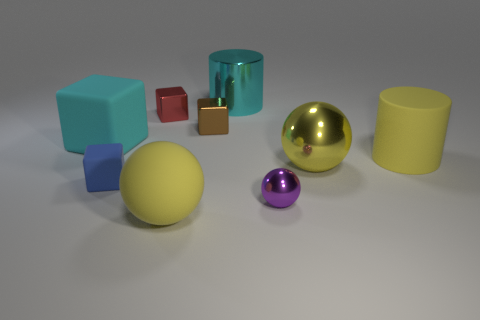Subtract all red blocks. How many yellow balls are left? 2 Subtract all large yellow rubber balls. How many balls are left? 2 Subtract 2 blocks. How many blocks are left? 2 Add 1 large yellow shiny objects. How many objects exist? 10 Subtract all cyan blocks. How many blocks are left? 3 Subtract all cylinders. How many objects are left? 7 Subtract 0 green blocks. How many objects are left? 9 Subtract all purple blocks. Subtract all yellow cylinders. How many blocks are left? 4 Subtract all tiny green things. Subtract all large rubber cylinders. How many objects are left? 8 Add 4 big rubber balls. How many big rubber balls are left? 5 